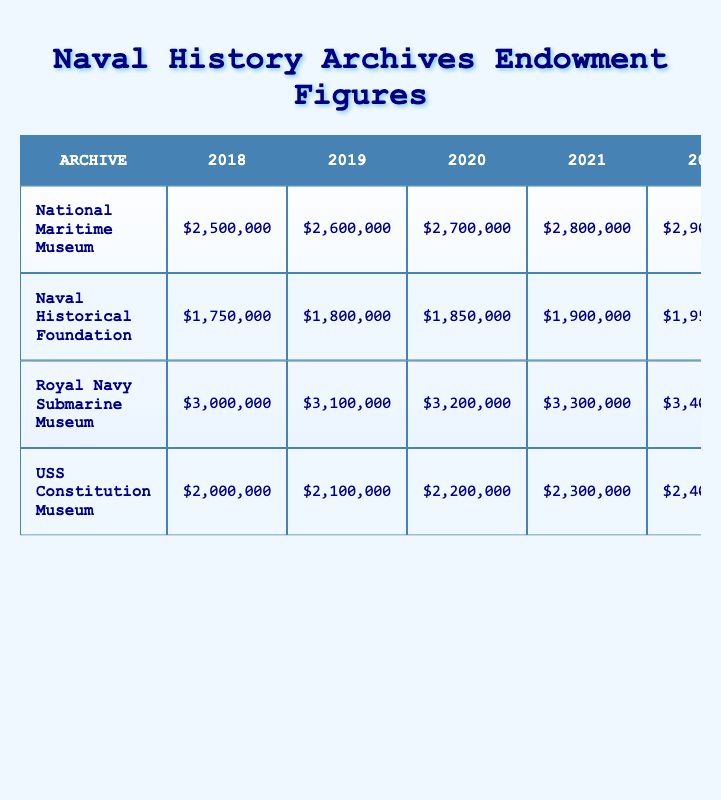What was the endowment for the USS Constitution Museum in 2020? The table shows that the endowment for the USS Constitution Museum in 2020 is $2,200,000.
Answer: $2,200,000 Which archive had the highest endowment in 2021? By examining the table for the year 2021, the Royal Navy Submarine Museum had the highest endowment at $3,300,000.
Answer: Royal Navy Submarine Museum What is the total endowment for the National Maritime Museum from 2018 to 2022? The endowment figures for the National Maritime Museum from 2018 to 2022 are $2,500,000, $2,600,000, $2,700,000, $2,800,000, and $2,900,000. Summing these amounts gives: 2,500,000 + 2,600,000 + 2,700,000 + 2,800,000 + 2,900,000 = $13,500,000.
Answer: $13,500,000 Did the endowment for the Naval Historical Foundation increase every year from 2018 to 2022? Reviewing the endowment figures reveals that the amounts for the Naval Historical Foundation are $1,750,000, $1,800,000, $1,850,000, $1,900,000, and $1,950,000, which show a consistent increase each year.
Answer: Yes What was the average endowment for the Royal Navy Submarine Museum over the five years? The endowment figures for the Royal Navy Submarine Museum are $3,000,000, $3,100,000, $3,200,000, $3,300,000, and $3,400,000. The total sum is 3,000,000 + 3,100,000 + 3,200,000 + 3,300,000 + 3,400,000 = $15,000,000. To find the average, we divide by the number of years (5): 15,000,000 / 5 = $3,000,000.
Answer: $3,000,000 What was the difference in endowment between the National Maritime Museum in 2019 and the USS Constitution Museum in 2021? The endowment for the National Maritime Museum in 2019 is $2,600,000, and for the USS Constitution Museum in 2021, it is $2,300,000. The difference is calculated as $2,600,000 - $2,300,000 = $300,000.
Answer: $300,000 